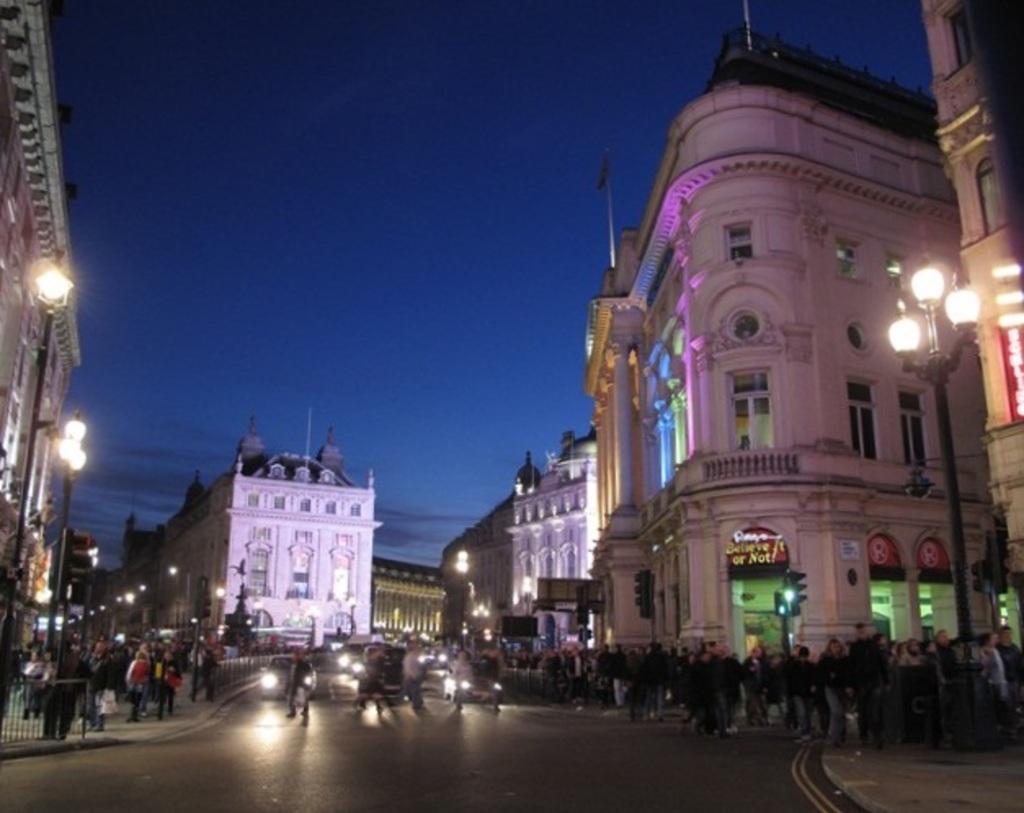Can you describe this image briefly? In this image, we can see some buildings and persons. There are cars on the road. There are lights on the left and on the right side of the image. There is a sky at the top of the image. 